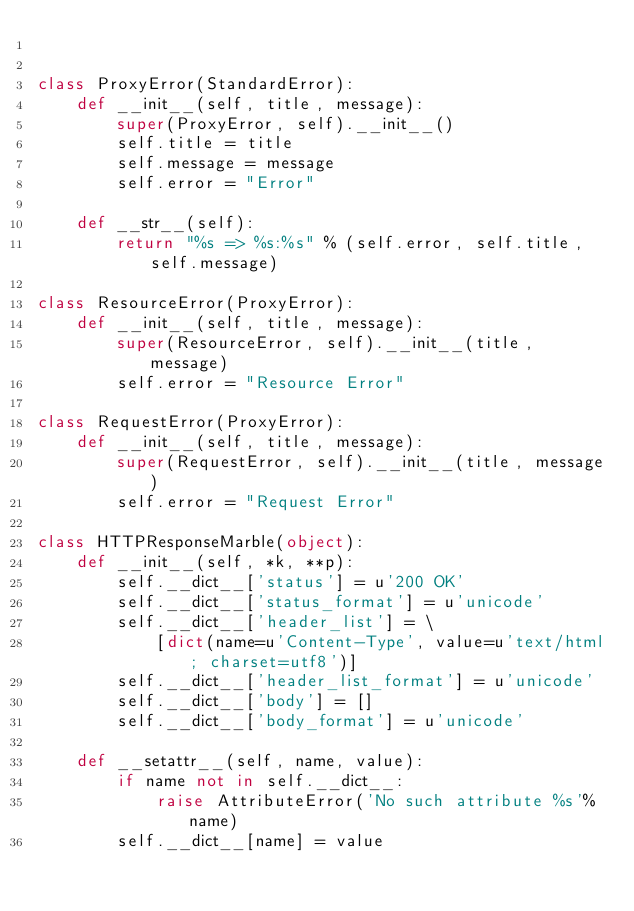<code> <loc_0><loc_0><loc_500><loc_500><_Python_>

class ProxyError(StandardError):
    def __init__(self, title, message):
        super(ProxyError, self).__init__()
        self.title = title
        self.message = message
        self.error = "Error"

    def __str__(self):
        return "%s => %s:%s" % (self.error, self.title, self.message)

class ResourceError(ProxyError):
    def __init__(self, title, message):
        super(ResourceError, self).__init__(title, message)
        self.error = "Resource Error"

class RequestError(ProxyError):
    def __init__(self, title, message):
        super(RequestError, self).__init__(title, message)
        self.error = "Request Error"

class HTTPResponseMarble(object):
    def __init__(self, *k, **p):
        self.__dict__['status'] = u'200 OK'
        self.__dict__['status_format'] = u'unicode'
        self.__dict__['header_list'] = \
            [dict(name=u'Content-Type', value=u'text/html; charset=utf8')]
        self.__dict__['header_list_format'] = u'unicode'
        self.__dict__['body'] = []
        self.__dict__['body_format'] = u'unicode'

    def __setattr__(self, name, value):
        if name not in self.__dict__:
            raise AttributeError('No such attribute %s'%name)
        self.__dict__[name] = value
</code> 